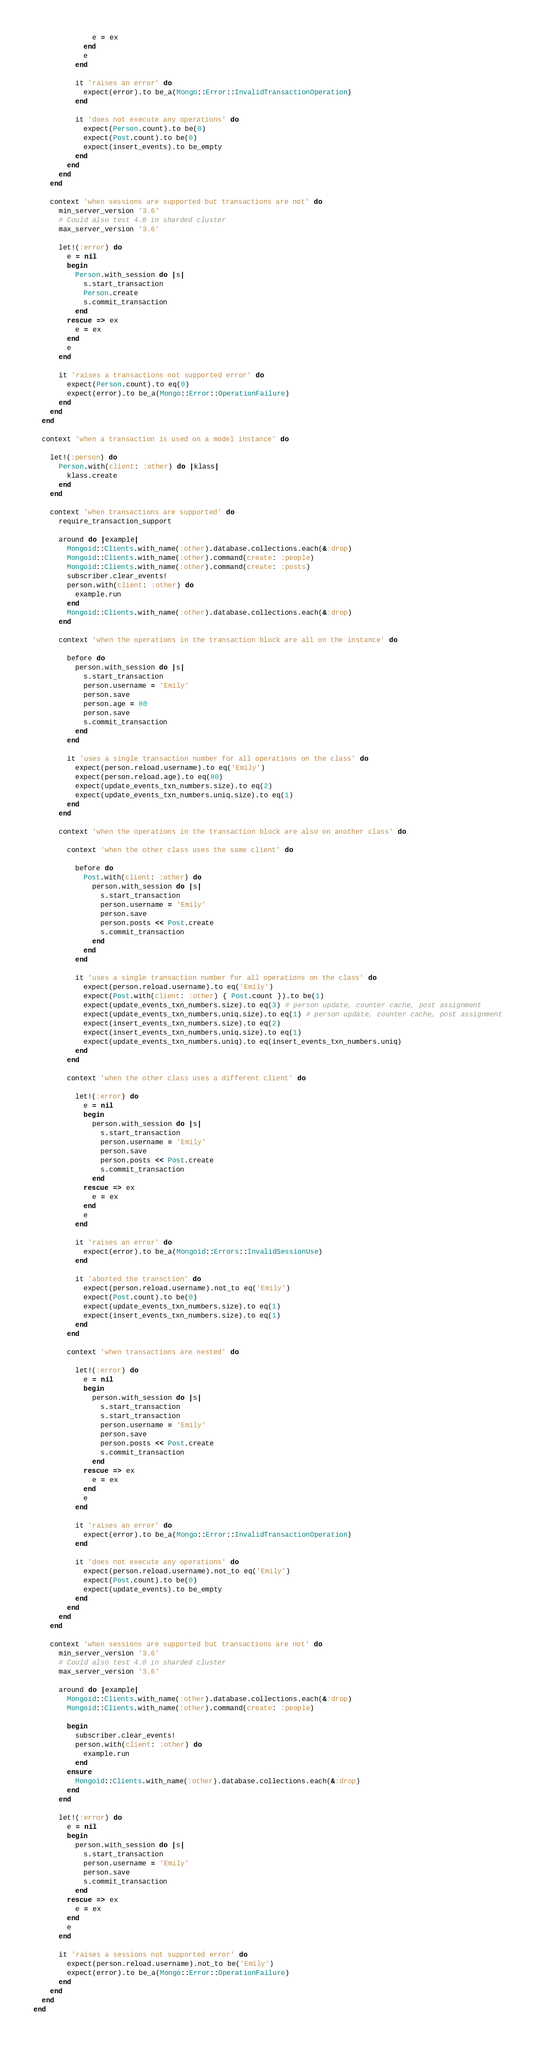Convert code to text. <code><loc_0><loc_0><loc_500><loc_500><_Ruby_>              e = ex
            end
            e
          end

          it 'raises an error' do
            expect(error).to be_a(Mongo::Error::InvalidTransactionOperation)
          end

          it 'does not execute any operations' do
            expect(Person.count).to be(0)
            expect(Post.count).to be(0)
            expect(insert_events).to be_empty
          end
        end
      end
    end

    context 'when sessions are supported but transactions are not' do
      min_server_version '3.6'
      # Could also test 4.0 in sharded cluster
      max_server_version '3.6'

      let!(:error) do
        e = nil
        begin
          Person.with_session do |s|
            s.start_transaction
            Person.create
            s.commit_transaction
          end
        rescue => ex
          e = ex
        end
        e
      end

      it 'raises a transactions not supported error' do
        expect(Person.count).to eq(0)
        expect(error).to be_a(Mongo::Error::OperationFailure)
      end
    end
  end

  context 'when a transaction is used on a model instance' do

    let!(:person) do
      Person.with(client: :other) do |klass|
        klass.create
      end
    end

    context 'when transactions are supported' do
      require_transaction_support

      around do |example|
        Mongoid::Clients.with_name(:other).database.collections.each(&:drop)
        Mongoid::Clients.with_name(:other).command(create: :people)
        Mongoid::Clients.with_name(:other).command(create: :posts)
        subscriber.clear_events!
        person.with(client: :other) do
          example.run
        end
        Mongoid::Clients.with_name(:other).database.collections.each(&:drop)
      end

      context 'when the operations in the transaction block are all on the instance' do

        before do
          person.with_session do |s|
            s.start_transaction
            person.username = 'Emily'
            person.save
            person.age = 80
            person.save
            s.commit_transaction
          end
        end

        it 'uses a single transaction number for all operations on the class' do
          expect(person.reload.username).to eq('Emily')
          expect(person.reload.age).to eq(80)
          expect(update_events_txn_numbers.size).to eq(2)
          expect(update_events_txn_numbers.uniq.size).to eq(1)
        end
      end

      context 'when the operations in the transaction block are also on another class' do

        context 'when the other class uses the same client' do

          before do
            Post.with(client: :other) do
              person.with_session do |s|
                s.start_transaction
                person.username = 'Emily'
                person.save
                person.posts << Post.create
                s.commit_transaction
              end
            end
          end

          it 'uses a single transaction number for all operations on the class' do
            expect(person.reload.username).to eq('Emily')
            expect(Post.with(client: :other) { Post.count }).to be(1)
            expect(update_events_txn_numbers.size).to eq(3) # person update, counter cache, post assignment
            expect(update_events_txn_numbers.uniq.size).to eq(1) # person update, counter cache, post assignment
            expect(insert_events_txn_numbers.size).to eq(2)
            expect(insert_events_txn_numbers.uniq.size).to eq(1)
            expect(update_events_txn_numbers.uniq).to eq(insert_events_txn_numbers.uniq)
          end
        end

        context 'when the other class uses a different client' do

          let!(:error) do
            e = nil
            begin
              person.with_session do |s|
                s.start_transaction
                person.username = 'Emily'
                person.save
                person.posts << Post.create
                s.commit_transaction
              end
            rescue => ex
              e = ex
            end
            e
          end

          it 'raises an error' do
            expect(error).to be_a(Mongoid::Errors::InvalidSessionUse)
          end

          it 'aborted the transction' do
            expect(person.reload.username).not_to eq('Emily')
            expect(Post.count).to be(0)
            expect(update_events_txn_numbers.size).to eq(1)
            expect(insert_events_txn_numbers.size).to eq(1)
          end
        end

        context 'when transactions are nested' do

          let!(:error) do
            e = nil
            begin
              person.with_session do |s|
                s.start_transaction
                s.start_transaction
                person.username = 'Emily'
                person.save
                person.posts << Post.create
                s.commit_transaction
              end
            rescue => ex
              e = ex
            end
            e
          end

          it 'raises an error' do
            expect(error).to be_a(Mongo::Error::InvalidTransactionOperation)
          end

          it 'does not execute any operations' do
            expect(person.reload.username).not_to eq('Emily')
            expect(Post.count).to be(0)
            expect(update_events).to be_empty
          end
        end
      end
    end

    context 'when sessions are supported but transactions are not' do
      min_server_version '3.6'
      # Could also test 4.0 in sharded cluster
      max_server_version '3.6'

      around do |example|
        Mongoid::Clients.with_name(:other).database.collections.each(&:drop)
        Mongoid::Clients.with_name(:other).command(create: :people)

        begin
          subscriber.clear_events!
          person.with(client: :other) do
            example.run
          end
        ensure
          Mongoid::Clients.with_name(:other).database.collections.each(&:drop)
        end
      end

      let!(:error) do
        e = nil
        begin
          person.with_session do |s|
            s.start_transaction
            person.username = 'Emily'
            person.save
            s.commit_transaction
          end
        rescue => ex
          e = ex
        end
        e
      end

      it 'raises a sessions not supported error' do
        expect(person.reload.username).not_to be('Emily')
        expect(error).to be_a(Mongo::Error::OperationFailure)
      end
    end
  end
end
</code> 